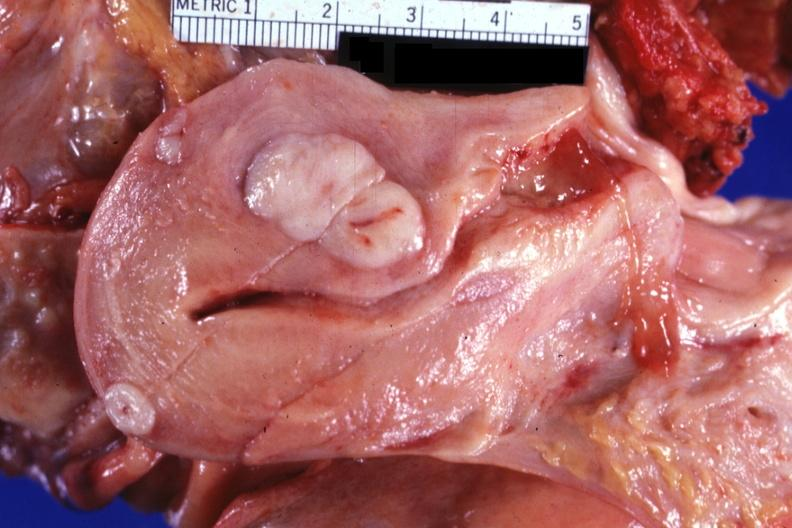does this image show sectioned uterus shown close-up with typical small myomas very good?
Answer the question using a single word or phrase. Yes 